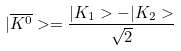<formula> <loc_0><loc_0><loc_500><loc_500>| \overline { K ^ { 0 } } > = \frac { | K _ { 1 } > - | K _ { 2 } > } { \sqrt { 2 } }</formula> 